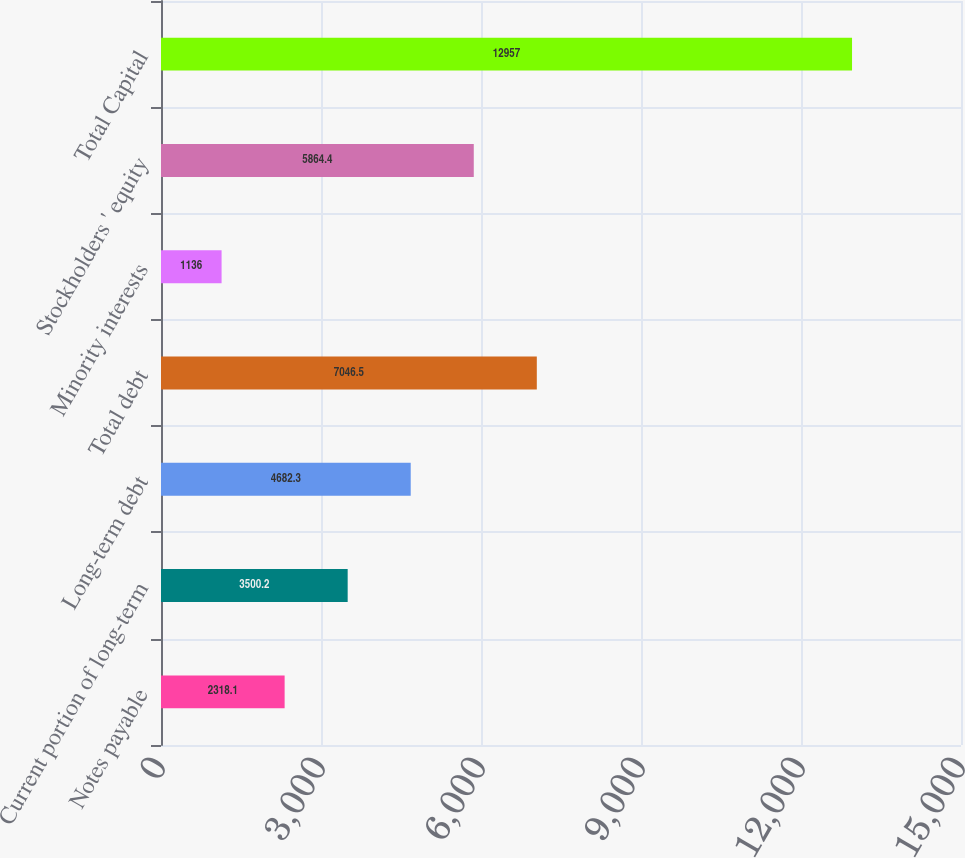Convert chart. <chart><loc_0><loc_0><loc_500><loc_500><bar_chart><fcel>Notes payable<fcel>Current portion of long-term<fcel>Long-term debt<fcel>Total debt<fcel>Minority interests<fcel>Stockholders ' equity<fcel>Total Capital<nl><fcel>2318.1<fcel>3500.2<fcel>4682.3<fcel>7046.5<fcel>1136<fcel>5864.4<fcel>12957<nl></chart> 